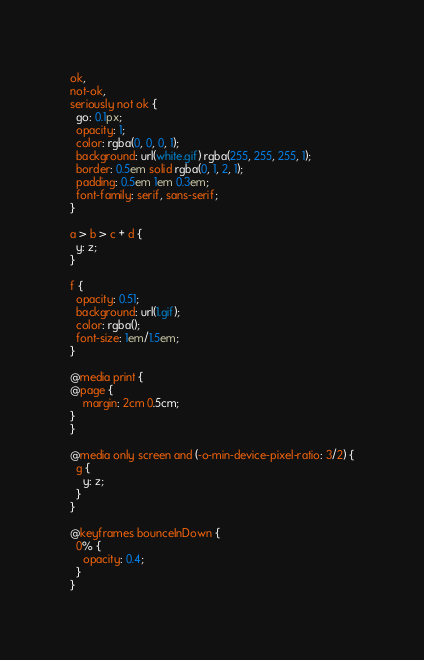<code> <loc_0><loc_0><loc_500><loc_500><_CSS_>ok,
not-ok,
seriously not ok {
  go: 0.1px;
  opacity: 1;
  color: rgba(0, 0, 0, 1);
  background: url(white.gif) rgba(255, 255, 255, 1);
  border: 0.5em solid rgba(0, 1, 2, 1);
  padding: 0.5em 1em 0.3em;
  font-family: serif, sans-serif;
}

a > b > c + d {
  y: z;
}

f {
  opacity: 0.51;
  background: url(1.gif);
  color: rgba();
  font-size: 1em/1.5em;
}

@media print {
@page {
    margin: 2cm 0.5cm;
}
}

@media only screen and (-o-min-device-pixel-ratio: 3/2) {
  g {
    y: z;
  }
}

@keyframes bounceInDown {
  0% {
    opacity: 0.4;
  }
}</code> 